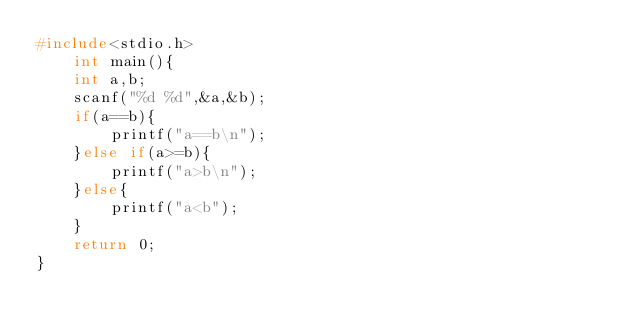Convert code to text. <code><loc_0><loc_0><loc_500><loc_500><_C_>#include<stdio.h>
	int main(){
	int a,b;
	scanf("%d %d",&a,&b);
	if(a==b){
		printf("a==b\n");
	}else if(a>=b){
		printf("a>b\n");
	}else{
		printf("a<b");
	}
	return 0;
}
</code> 